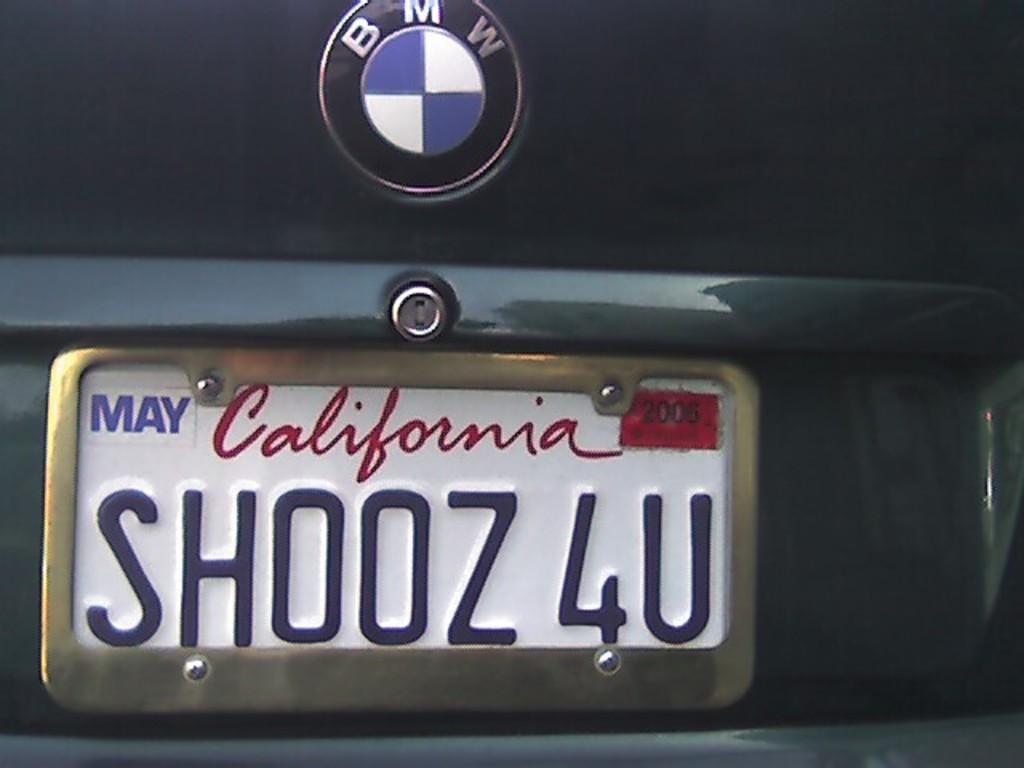<image>
Provide a brief description of the given image. a license plate that has shooz 4u on it 